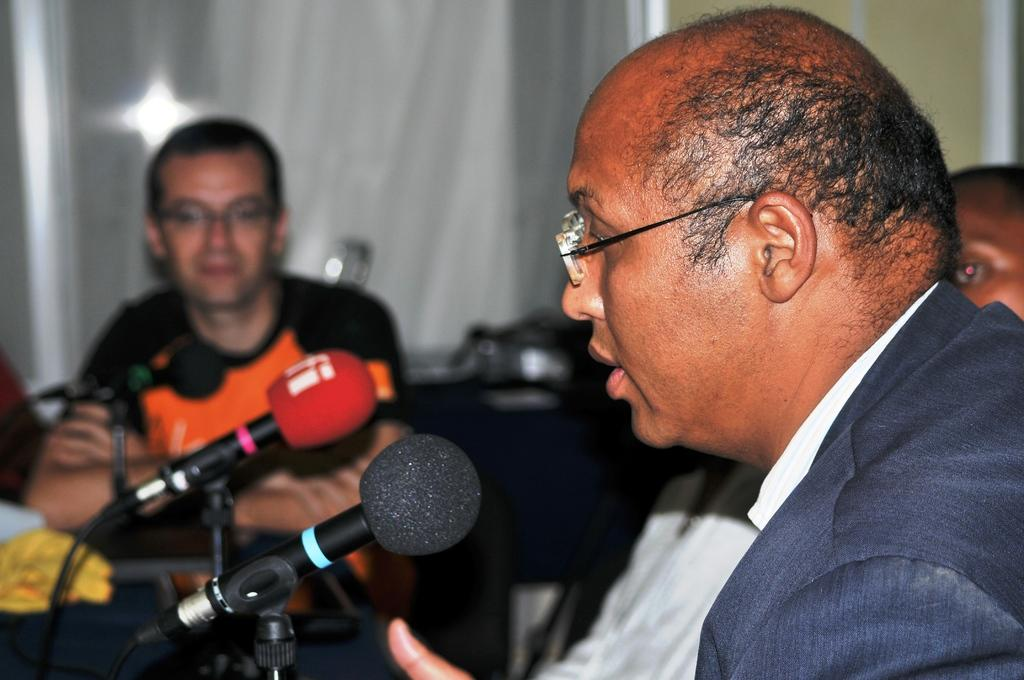What are the people in the image doing? There is a group of people sitting in the image. What type of event might be taking place based on the presence of miles in the image? The miles have stands in the image, which suggests that it might be a sports event or a race. What other objects can be seen on the table in the image? There are other objects on the table in the image, but their specific nature is not mentioned in the facts. What is visible in the background of the image? There is a wall in the background of the image. How many bags are being carried by the people in the image? There is no mention of bags in the image, so it is not possible to determine how many bags are being carried. 